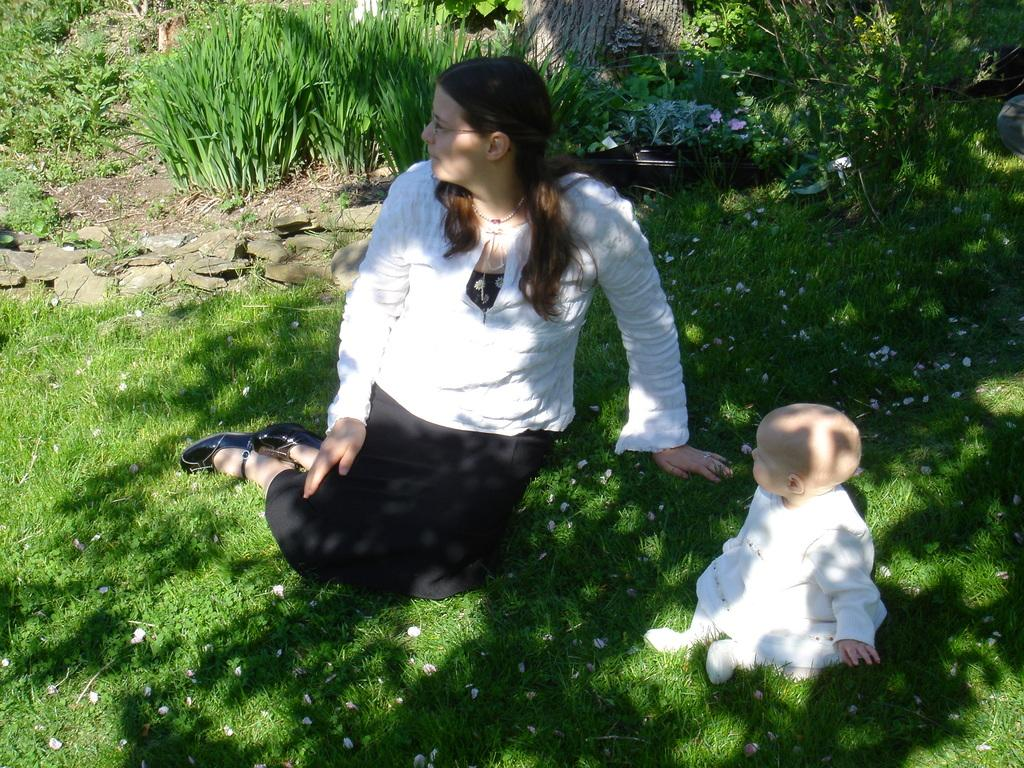Who is present in the image? There is a lady and a small girl in the image. What are they doing in the image? Both the lady and the small girl are sitting on the grassland. What can be seen in the background of the image? There is greenery and stones in the background of the image. What type of lettuce is being used as a cup by the lady in the image? There is no lettuce or cup present in the image. What kind of wall can be seen in the background of the image? There is no wall visible in the background of the image; it features greenery and stones. 